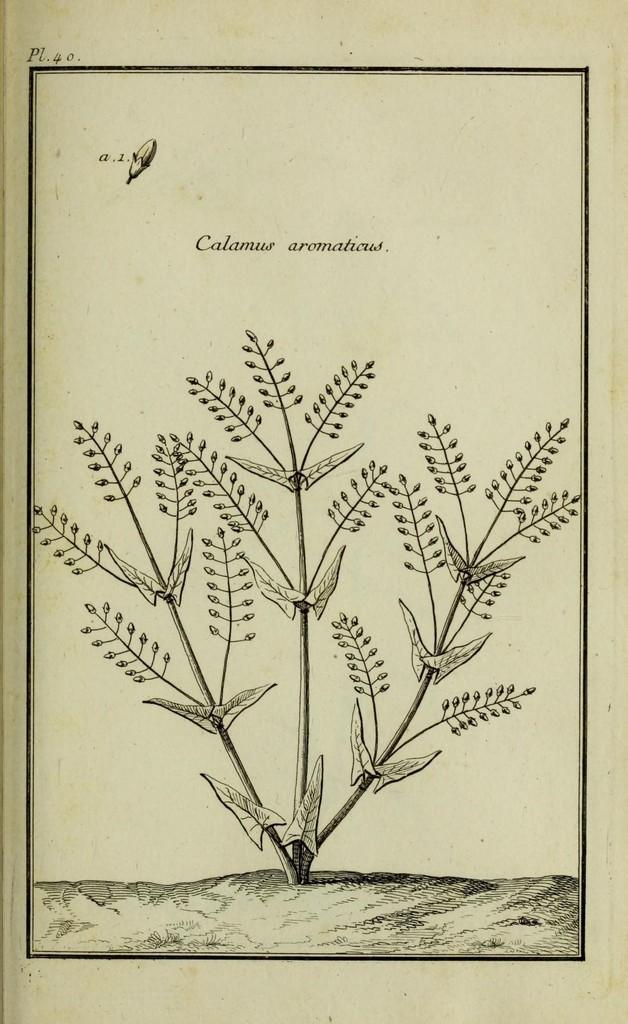What is the main subject of the image? The main subject of the image is a picture of a plant. What else can be seen in the image besides the plant? There is text in the image. What color is the background of the image? The background of the image is cream-colored. How does the flame change the appearance of the plant in the image? There is no flame present in the image, so it cannot change the appearance of the plant. 